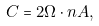Convert formula to latex. <formula><loc_0><loc_0><loc_500><loc_500>C = 2 { \Omega } \cdot { n } A ,</formula> 